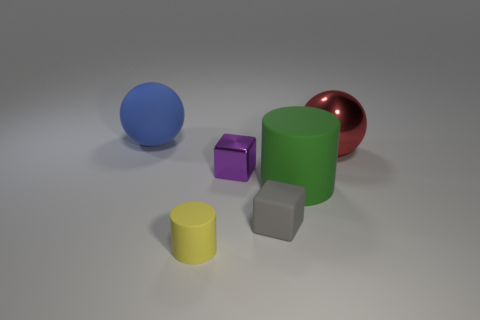There is a tiny purple object that is the same material as the large red object; what is its shape?
Your answer should be compact. Cube. Are there an equal number of red metal spheres in front of the yellow cylinder and big matte cylinders?
Make the answer very short. No. Does the sphere behind the large metallic sphere have the same material as the block that is on the right side of the small purple metallic cube?
Your response must be concise. Yes. There is a thing that is behind the shiny object that is on the right side of the large green thing; what is its shape?
Make the answer very short. Sphere. What is the color of the sphere that is made of the same material as the yellow cylinder?
Your answer should be very brief. Blue. Do the metallic sphere and the large matte ball have the same color?
Offer a terse response. No. What shape is the red thing that is the same size as the green object?
Your answer should be very brief. Sphere. What is the size of the red thing?
Offer a terse response. Large. There is a block in front of the metal block; does it have the same size as the sphere that is to the left of the tiny purple metal thing?
Your answer should be very brief. No. There is a matte cylinder that is to the right of the rubber cylinder that is in front of the green rubber cylinder; what color is it?
Make the answer very short. Green. 